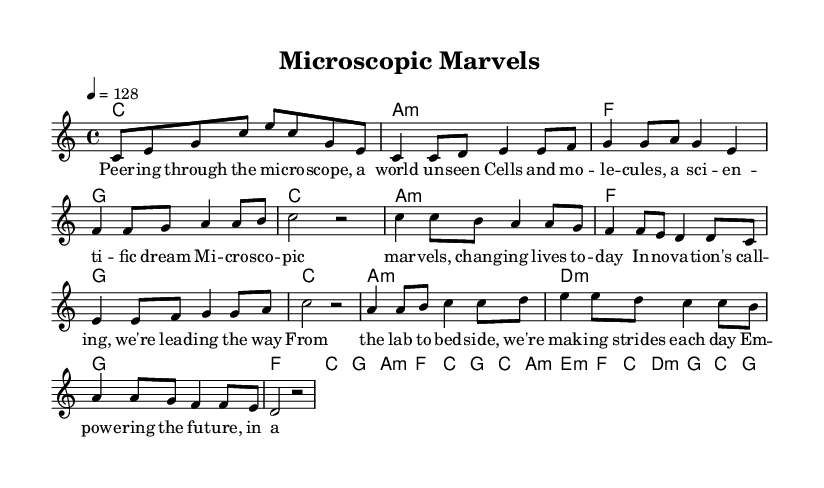What is the key signature of this music? The key signature is C major, which has no sharps or flats.
Answer: C major What is the time signature of this music? The time signature is indicated at the beginning of the score as 4/4, meaning there are four beats in each measure.
Answer: 4/4 What is the tempo marking for this piece? The tempo marking is found at the beginning of the score, which states that the piece should be played at a tempo of 128 beats per minute.
Answer: 128 How many measures are in the chorus section? By counting the measures in the chorus section from the score, we find there are four measures.
Answer: Four What unique thematic subject is the song about? The lyrics and overall theme of the music indicate that it focuses on scientific discoveries and breakthroughs.
Answer: Scientific discoveries What type of musical form is primarily used in this piece? The piece follows a typical pop song structure that includes verses, a chorus, and a bridge, which indicates a common verse-chorus form.
Answer: Verse-chorus form Which lyrical section emphasizes empowerment and innovation? The bridge section of the lyrics explicitly mentions "empowering the future," which aligns with themes of empowerment and innovation.
Answer: Bridge 